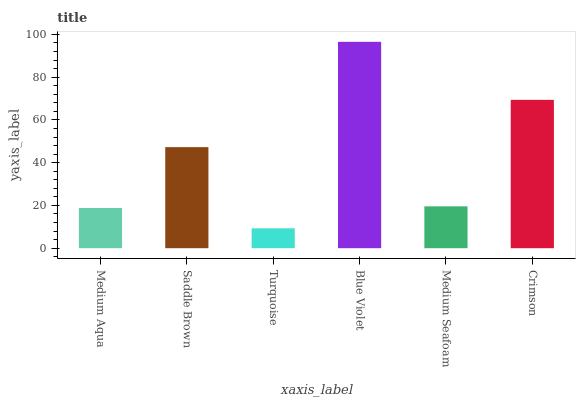Is Turquoise the minimum?
Answer yes or no. Yes. Is Blue Violet the maximum?
Answer yes or no. Yes. Is Saddle Brown the minimum?
Answer yes or no. No. Is Saddle Brown the maximum?
Answer yes or no. No. Is Saddle Brown greater than Medium Aqua?
Answer yes or no. Yes. Is Medium Aqua less than Saddle Brown?
Answer yes or no. Yes. Is Medium Aqua greater than Saddle Brown?
Answer yes or no. No. Is Saddle Brown less than Medium Aqua?
Answer yes or no. No. Is Saddle Brown the high median?
Answer yes or no. Yes. Is Medium Seafoam the low median?
Answer yes or no. Yes. Is Medium Aqua the high median?
Answer yes or no. No. Is Saddle Brown the low median?
Answer yes or no. No. 